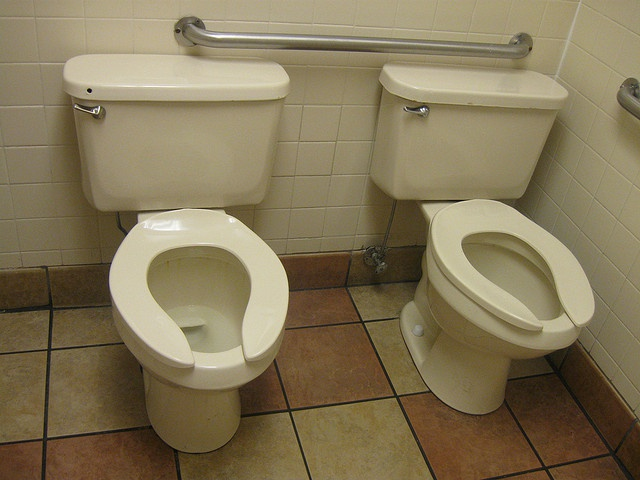Describe the objects in this image and their specific colors. I can see toilet in gray, olive, and tan tones and toilet in gray, beige, olive, and tan tones in this image. 